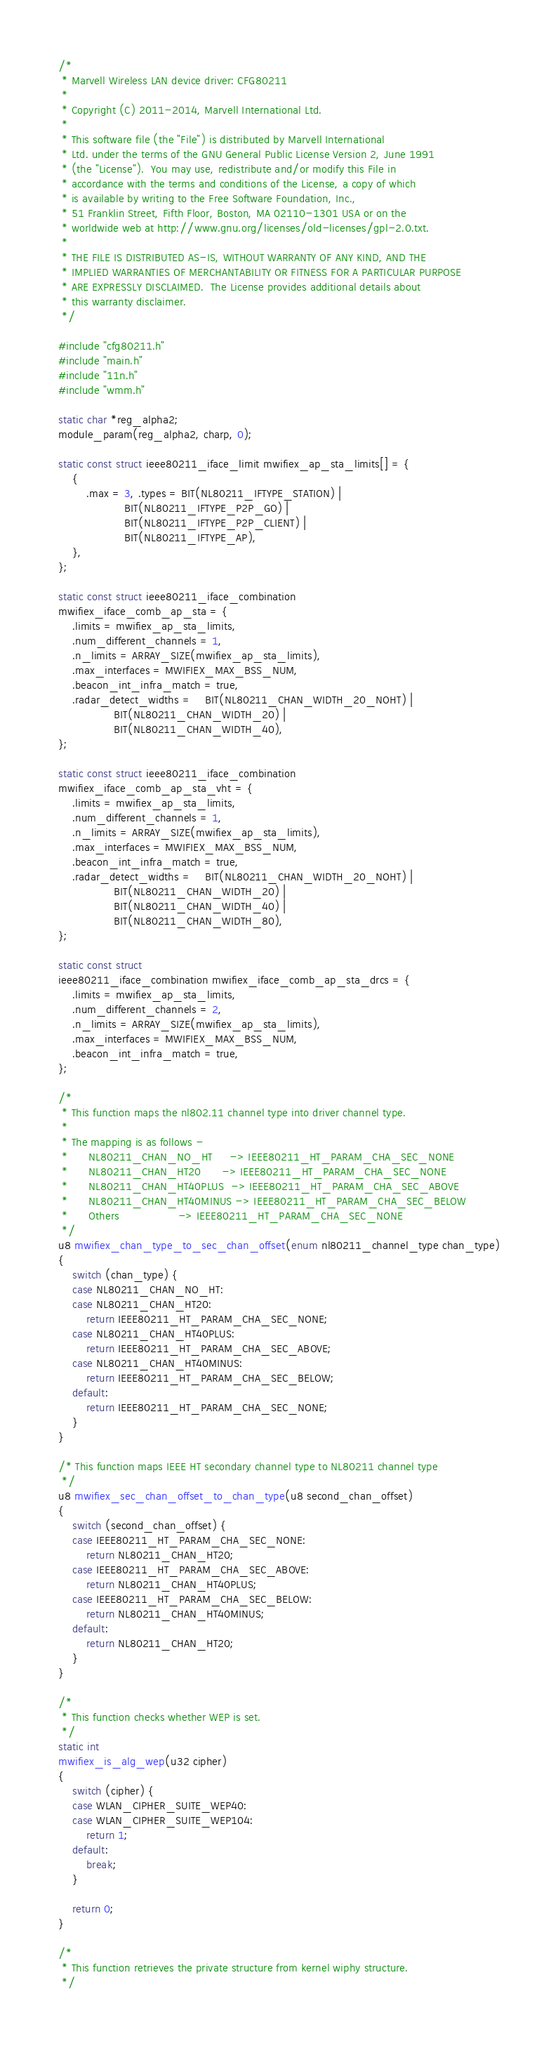Convert code to text. <code><loc_0><loc_0><loc_500><loc_500><_C_>/*
 * Marvell Wireless LAN device driver: CFG80211
 *
 * Copyright (C) 2011-2014, Marvell International Ltd.
 *
 * This software file (the "File") is distributed by Marvell International
 * Ltd. under the terms of the GNU General Public License Version 2, June 1991
 * (the "License").  You may use, redistribute and/or modify this File in
 * accordance with the terms and conditions of the License, a copy of which
 * is available by writing to the Free Software Foundation, Inc.,
 * 51 Franklin Street, Fifth Floor, Boston, MA 02110-1301 USA or on the
 * worldwide web at http://www.gnu.org/licenses/old-licenses/gpl-2.0.txt.
 *
 * THE FILE IS DISTRIBUTED AS-IS, WITHOUT WARRANTY OF ANY KIND, AND THE
 * IMPLIED WARRANTIES OF MERCHANTABILITY OR FITNESS FOR A PARTICULAR PURPOSE
 * ARE EXPRESSLY DISCLAIMED.  The License provides additional details about
 * this warranty disclaimer.
 */

#include "cfg80211.h"
#include "main.h"
#include "11n.h"
#include "wmm.h"

static char *reg_alpha2;
module_param(reg_alpha2, charp, 0);

static const struct ieee80211_iface_limit mwifiex_ap_sta_limits[] = {
	{
		.max = 3, .types = BIT(NL80211_IFTYPE_STATION) |
				   BIT(NL80211_IFTYPE_P2P_GO) |
				   BIT(NL80211_IFTYPE_P2P_CLIENT) |
				   BIT(NL80211_IFTYPE_AP),
	},
};

static const struct ieee80211_iface_combination
mwifiex_iface_comb_ap_sta = {
	.limits = mwifiex_ap_sta_limits,
	.num_different_channels = 1,
	.n_limits = ARRAY_SIZE(mwifiex_ap_sta_limits),
	.max_interfaces = MWIFIEX_MAX_BSS_NUM,
	.beacon_int_infra_match = true,
	.radar_detect_widths =	BIT(NL80211_CHAN_WIDTH_20_NOHT) |
				BIT(NL80211_CHAN_WIDTH_20) |
				BIT(NL80211_CHAN_WIDTH_40),
};

static const struct ieee80211_iface_combination
mwifiex_iface_comb_ap_sta_vht = {
	.limits = mwifiex_ap_sta_limits,
	.num_different_channels = 1,
	.n_limits = ARRAY_SIZE(mwifiex_ap_sta_limits),
	.max_interfaces = MWIFIEX_MAX_BSS_NUM,
	.beacon_int_infra_match = true,
	.radar_detect_widths =	BIT(NL80211_CHAN_WIDTH_20_NOHT) |
				BIT(NL80211_CHAN_WIDTH_20) |
				BIT(NL80211_CHAN_WIDTH_40) |
				BIT(NL80211_CHAN_WIDTH_80),
};

static const struct
ieee80211_iface_combination mwifiex_iface_comb_ap_sta_drcs = {
	.limits = mwifiex_ap_sta_limits,
	.num_different_channels = 2,
	.n_limits = ARRAY_SIZE(mwifiex_ap_sta_limits),
	.max_interfaces = MWIFIEX_MAX_BSS_NUM,
	.beacon_int_infra_match = true,
};

/*
 * This function maps the nl802.11 channel type into driver channel type.
 *
 * The mapping is as follows -
 *      NL80211_CHAN_NO_HT     -> IEEE80211_HT_PARAM_CHA_SEC_NONE
 *      NL80211_CHAN_HT20      -> IEEE80211_HT_PARAM_CHA_SEC_NONE
 *      NL80211_CHAN_HT40PLUS  -> IEEE80211_HT_PARAM_CHA_SEC_ABOVE
 *      NL80211_CHAN_HT40MINUS -> IEEE80211_HT_PARAM_CHA_SEC_BELOW
 *      Others                 -> IEEE80211_HT_PARAM_CHA_SEC_NONE
 */
u8 mwifiex_chan_type_to_sec_chan_offset(enum nl80211_channel_type chan_type)
{
	switch (chan_type) {
	case NL80211_CHAN_NO_HT:
	case NL80211_CHAN_HT20:
		return IEEE80211_HT_PARAM_CHA_SEC_NONE;
	case NL80211_CHAN_HT40PLUS:
		return IEEE80211_HT_PARAM_CHA_SEC_ABOVE;
	case NL80211_CHAN_HT40MINUS:
		return IEEE80211_HT_PARAM_CHA_SEC_BELOW;
	default:
		return IEEE80211_HT_PARAM_CHA_SEC_NONE;
	}
}

/* This function maps IEEE HT secondary channel type to NL80211 channel type
 */
u8 mwifiex_sec_chan_offset_to_chan_type(u8 second_chan_offset)
{
	switch (second_chan_offset) {
	case IEEE80211_HT_PARAM_CHA_SEC_NONE:
		return NL80211_CHAN_HT20;
	case IEEE80211_HT_PARAM_CHA_SEC_ABOVE:
		return NL80211_CHAN_HT40PLUS;
	case IEEE80211_HT_PARAM_CHA_SEC_BELOW:
		return NL80211_CHAN_HT40MINUS;
	default:
		return NL80211_CHAN_HT20;
	}
}

/*
 * This function checks whether WEP is set.
 */
static int
mwifiex_is_alg_wep(u32 cipher)
{
	switch (cipher) {
	case WLAN_CIPHER_SUITE_WEP40:
	case WLAN_CIPHER_SUITE_WEP104:
		return 1;
	default:
		break;
	}

	return 0;
}

/*
 * This function retrieves the private structure from kernel wiphy structure.
 */</code> 